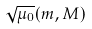Convert formula to latex. <formula><loc_0><loc_0><loc_500><loc_500>\sqrt { \mu _ { 0 } } ( m , M )</formula> 